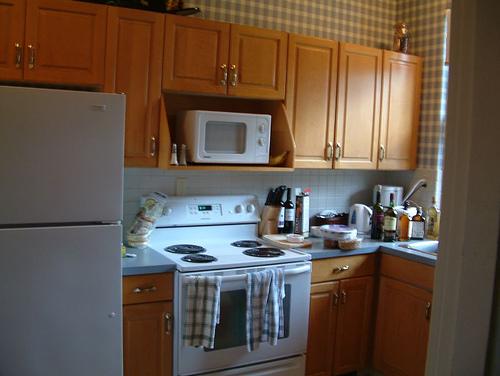What design is on the towel?
Be succinct. Plaid. Is there a stainless steel appliance in the picture?
Short answer required. No. Have they decorated the refrigerator?
Be succinct. No. Is the oven on?
Write a very short answer. No. Is the towel to the left checkered?
Write a very short answer. Yes. What powers the stove top?
Short answer required. Electricity. Are the towels dirty?
Give a very brief answer. No. Are the stove and oven one appliance?
Give a very brief answer. Yes. What is in the bottles on the counter?
Answer briefly. Wine. Is the cabinet open or closed?
Short answer required. Closed. 